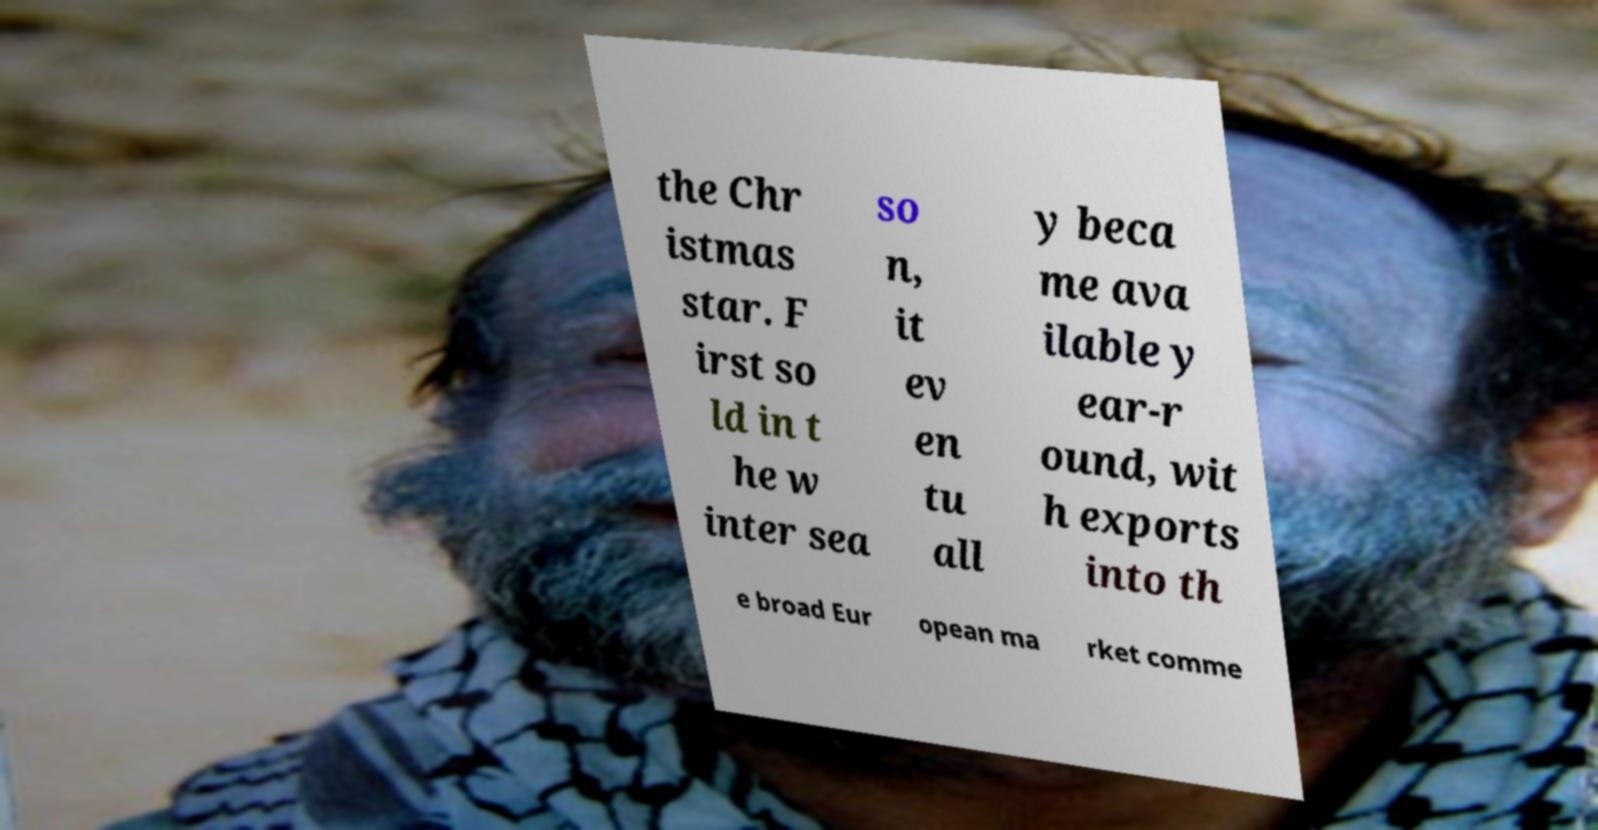Can you accurately transcribe the text from the provided image for me? the Chr istmas star. F irst so ld in t he w inter sea so n, it ev en tu all y beca me ava ilable y ear-r ound, wit h exports into th e broad Eur opean ma rket comme 